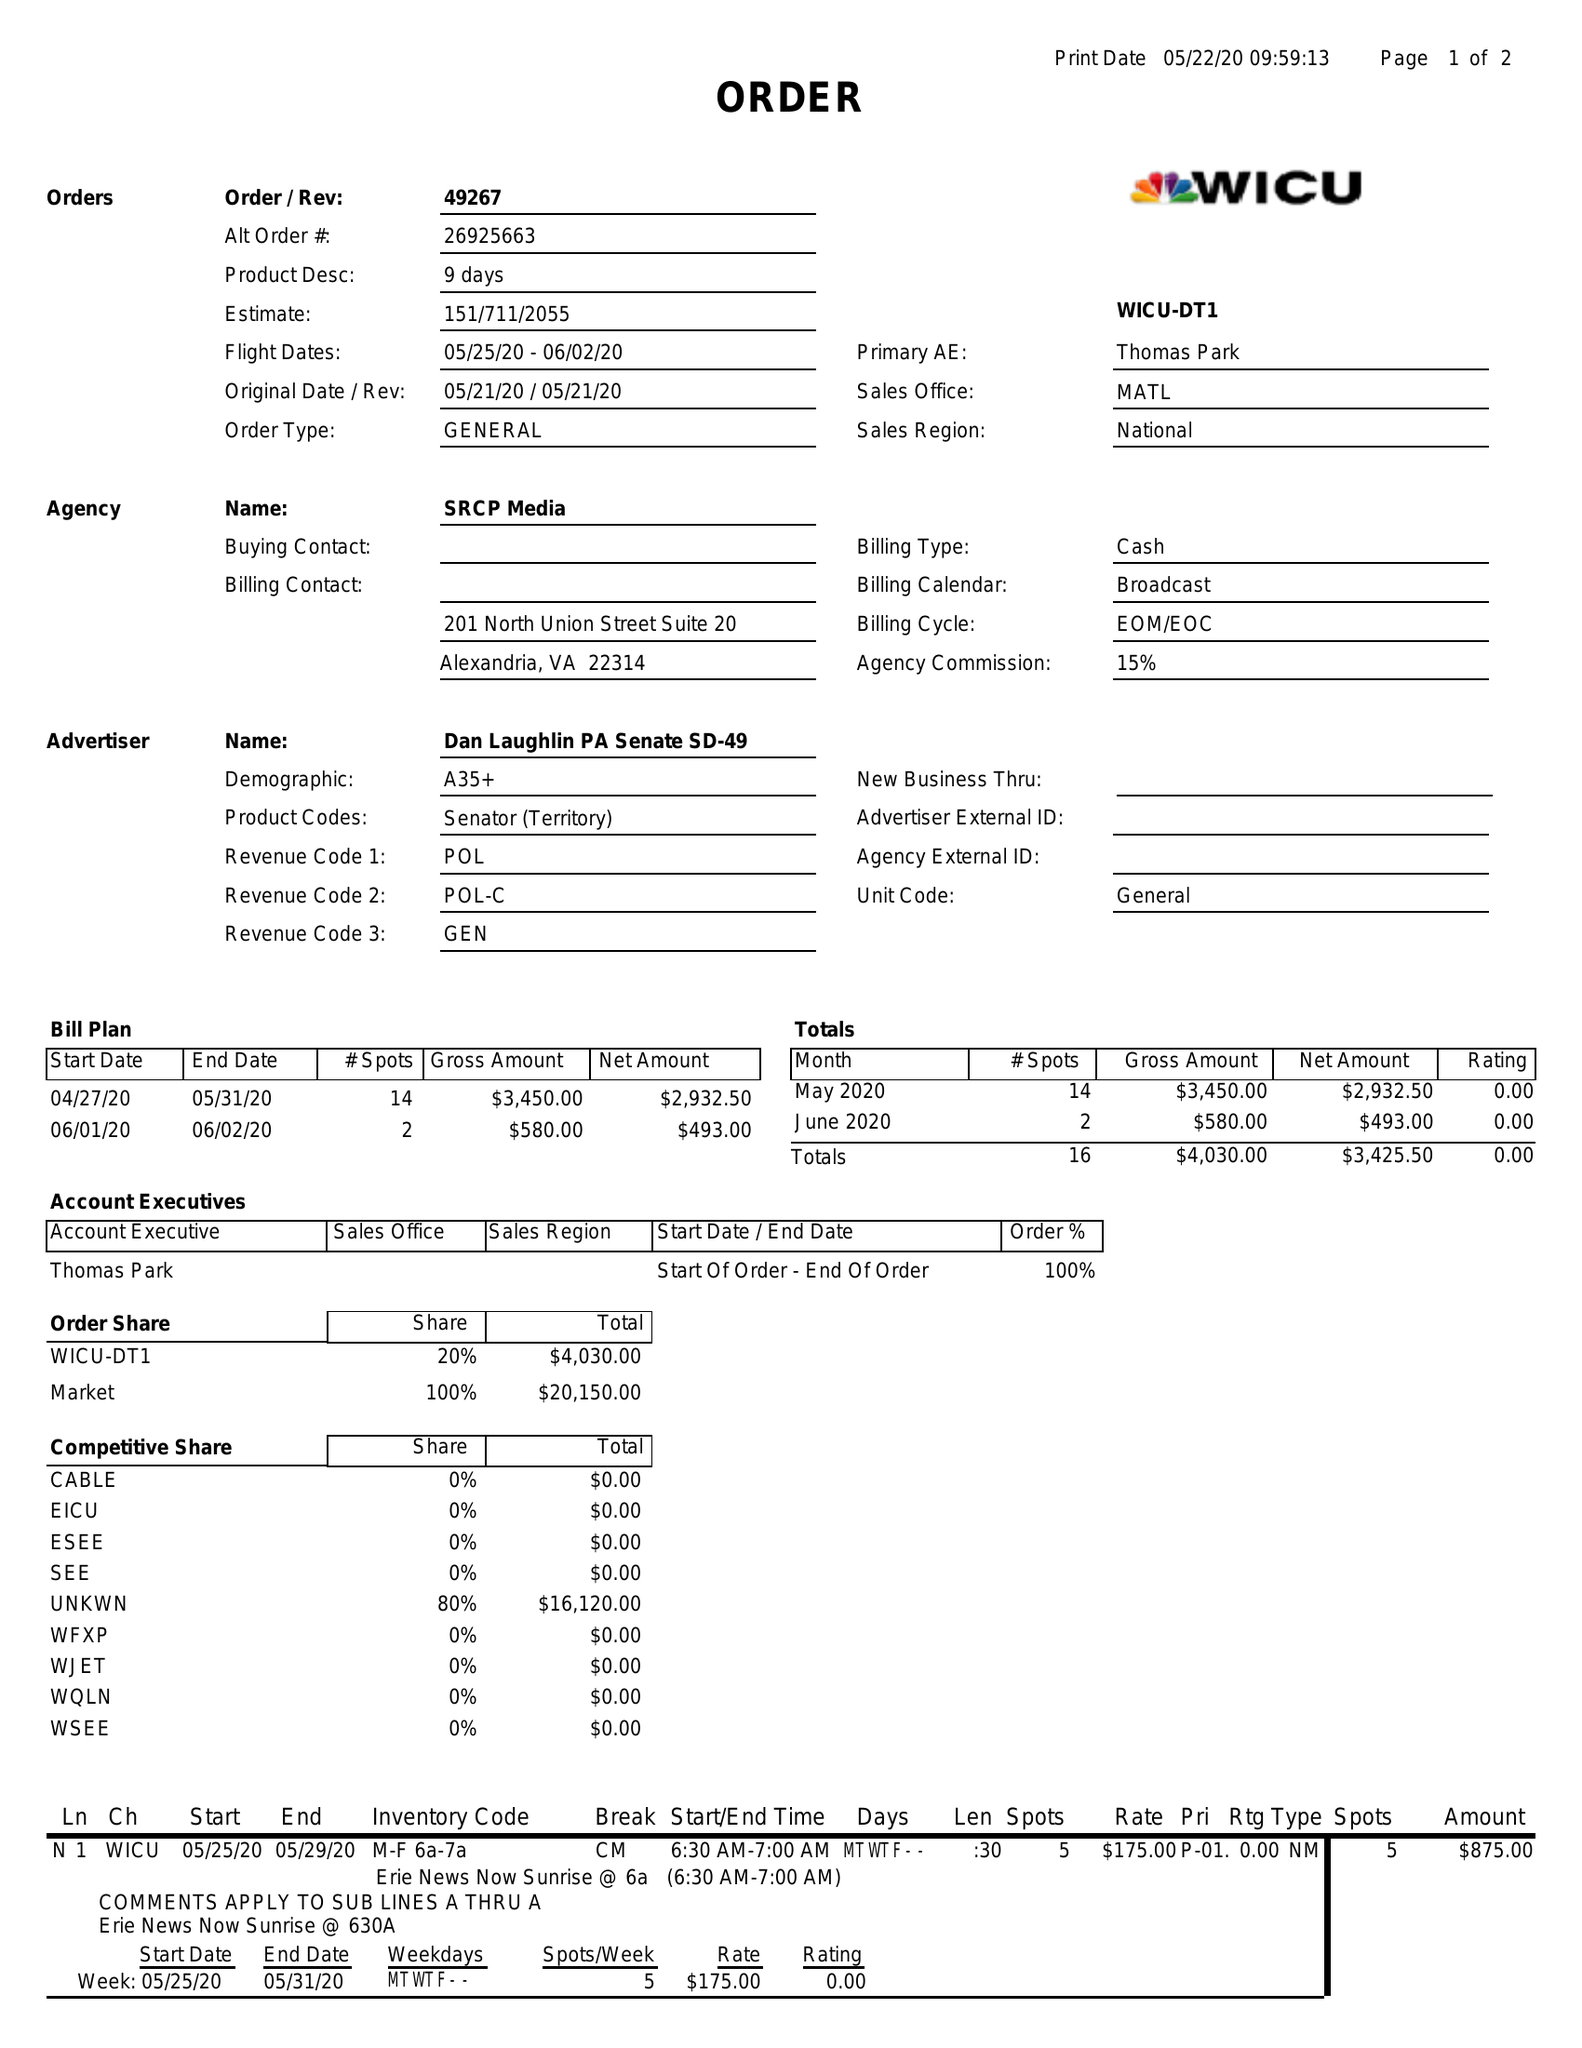What is the value for the advertiser?
Answer the question using a single word or phrase. DAN LAUGHLIN PA SENATE SD-49 